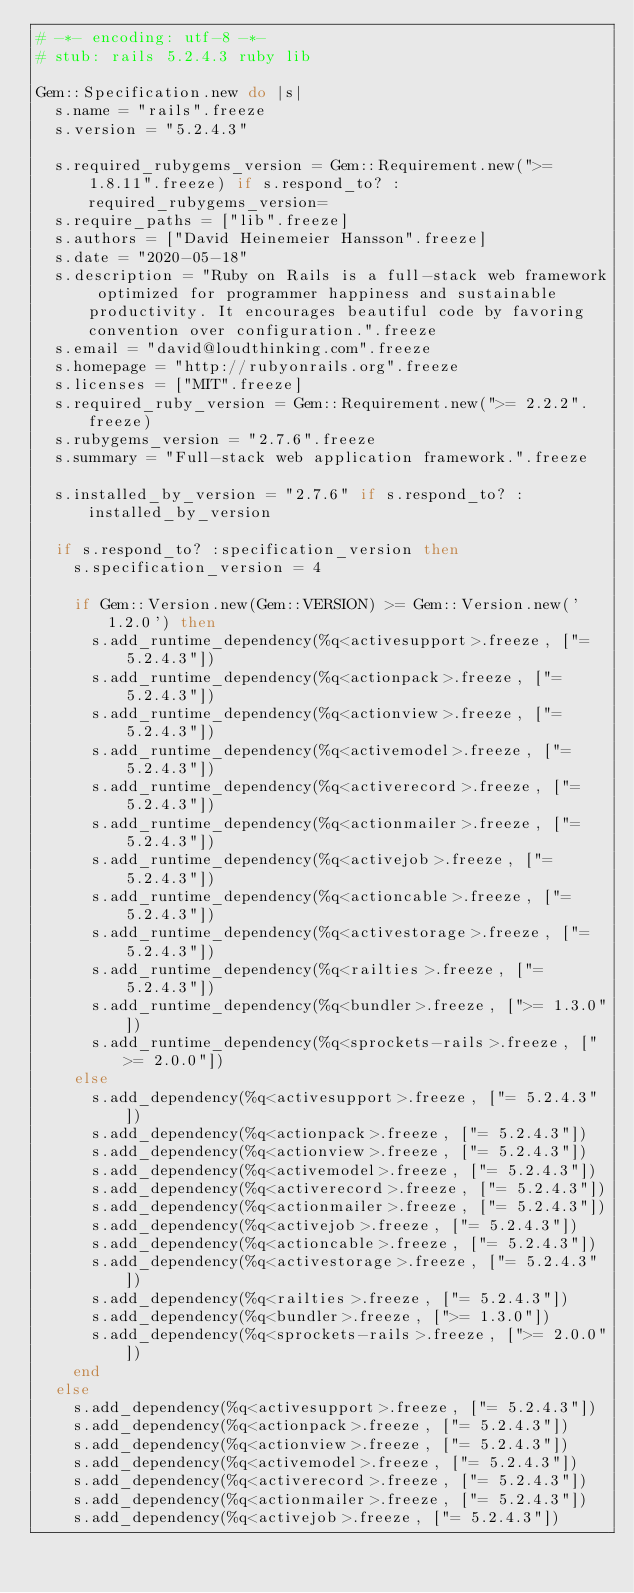Convert code to text. <code><loc_0><loc_0><loc_500><loc_500><_Ruby_># -*- encoding: utf-8 -*-
# stub: rails 5.2.4.3 ruby lib

Gem::Specification.new do |s|
  s.name = "rails".freeze
  s.version = "5.2.4.3"

  s.required_rubygems_version = Gem::Requirement.new(">= 1.8.11".freeze) if s.respond_to? :required_rubygems_version=
  s.require_paths = ["lib".freeze]
  s.authors = ["David Heinemeier Hansson".freeze]
  s.date = "2020-05-18"
  s.description = "Ruby on Rails is a full-stack web framework optimized for programmer happiness and sustainable productivity. It encourages beautiful code by favoring convention over configuration.".freeze
  s.email = "david@loudthinking.com".freeze
  s.homepage = "http://rubyonrails.org".freeze
  s.licenses = ["MIT".freeze]
  s.required_ruby_version = Gem::Requirement.new(">= 2.2.2".freeze)
  s.rubygems_version = "2.7.6".freeze
  s.summary = "Full-stack web application framework.".freeze

  s.installed_by_version = "2.7.6" if s.respond_to? :installed_by_version

  if s.respond_to? :specification_version then
    s.specification_version = 4

    if Gem::Version.new(Gem::VERSION) >= Gem::Version.new('1.2.0') then
      s.add_runtime_dependency(%q<activesupport>.freeze, ["= 5.2.4.3"])
      s.add_runtime_dependency(%q<actionpack>.freeze, ["= 5.2.4.3"])
      s.add_runtime_dependency(%q<actionview>.freeze, ["= 5.2.4.3"])
      s.add_runtime_dependency(%q<activemodel>.freeze, ["= 5.2.4.3"])
      s.add_runtime_dependency(%q<activerecord>.freeze, ["= 5.2.4.3"])
      s.add_runtime_dependency(%q<actionmailer>.freeze, ["= 5.2.4.3"])
      s.add_runtime_dependency(%q<activejob>.freeze, ["= 5.2.4.3"])
      s.add_runtime_dependency(%q<actioncable>.freeze, ["= 5.2.4.3"])
      s.add_runtime_dependency(%q<activestorage>.freeze, ["= 5.2.4.3"])
      s.add_runtime_dependency(%q<railties>.freeze, ["= 5.2.4.3"])
      s.add_runtime_dependency(%q<bundler>.freeze, [">= 1.3.0"])
      s.add_runtime_dependency(%q<sprockets-rails>.freeze, [">= 2.0.0"])
    else
      s.add_dependency(%q<activesupport>.freeze, ["= 5.2.4.3"])
      s.add_dependency(%q<actionpack>.freeze, ["= 5.2.4.3"])
      s.add_dependency(%q<actionview>.freeze, ["= 5.2.4.3"])
      s.add_dependency(%q<activemodel>.freeze, ["= 5.2.4.3"])
      s.add_dependency(%q<activerecord>.freeze, ["= 5.2.4.3"])
      s.add_dependency(%q<actionmailer>.freeze, ["= 5.2.4.3"])
      s.add_dependency(%q<activejob>.freeze, ["= 5.2.4.3"])
      s.add_dependency(%q<actioncable>.freeze, ["= 5.2.4.3"])
      s.add_dependency(%q<activestorage>.freeze, ["= 5.2.4.3"])
      s.add_dependency(%q<railties>.freeze, ["= 5.2.4.3"])
      s.add_dependency(%q<bundler>.freeze, [">= 1.3.0"])
      s.add_dependency(%q<sprockets-rails>.freeze, [">= 2.0.0"])
    end
  else
    s.add_dependency(%q<activesupport>.freeze, ["= 5.2.4.3"])
    s.add_dependency(%q<actionpack>.freeze, ["= 5.2.4.3"])
    s.add_dependency(%q<actionview>.freeze, ["= 5.2.4.3"])
    s.add_dependency(%q<activemodel>.freeze, ["= 5.2.4.3"])
    s.add_dependency(%q<activerecord>.freeze, ["= 5.2.4.3"])
    s.add_dependency(%q<actionmailer>.freeze, ["= 5.2.4.3"])
    s.add_dependency(%q<activejob>.freeze, ["= 5.2.4.3"])</code> 